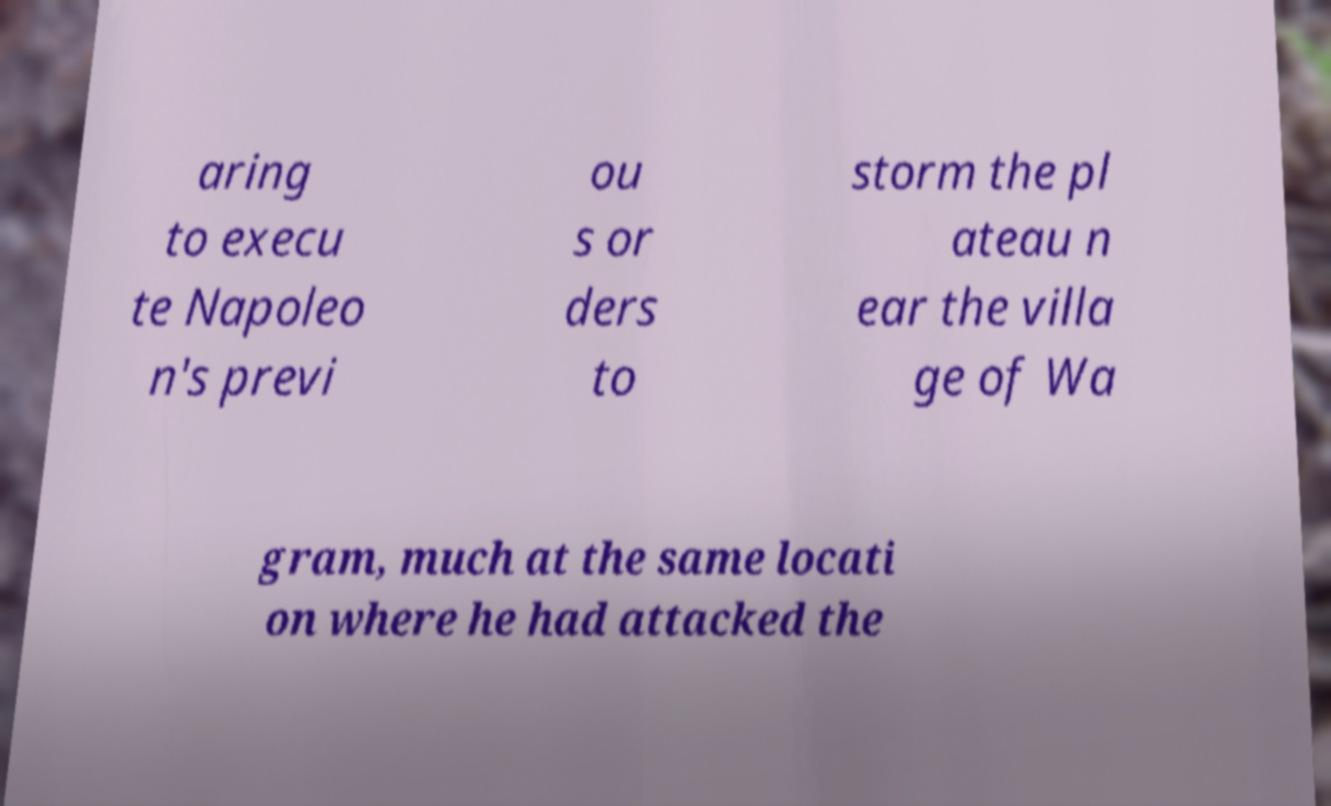Could you assist in decoding the text presented in this image and type it out clearly? aring to execu te Napoleo n's previ ou s or ders to storm the pl ateau n ear the villa ge of Wa gram, much at the same locati on where he had attacked the 